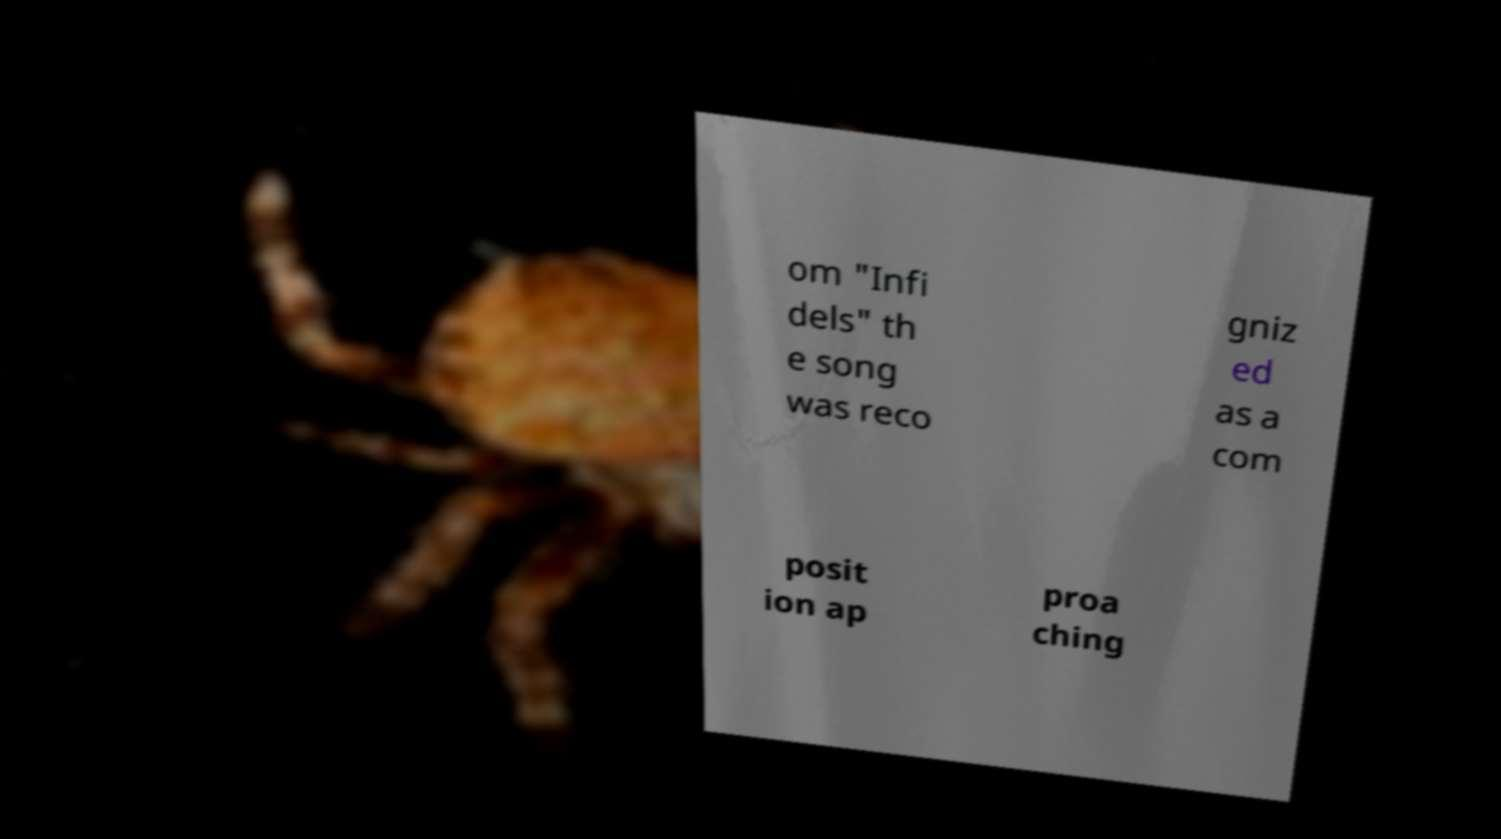Please identify and transcribe the text found in this image. om "Infi dels" th e song was reco gniz ed as a com posit ion ap proa ching 